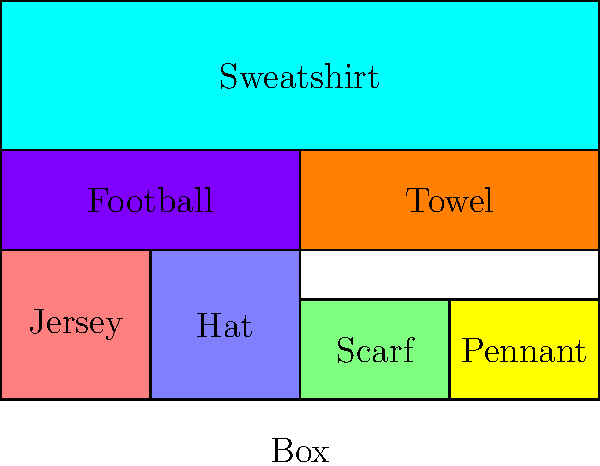You're packing Calgary Stampeders merchandise for shipping. Given a box with dimensions 6 units wide and 4 units tall, and the following items: a jersey (1.5x1.5), a hat (1.5x1.5), a scarf (1.5x1), a pennant (1.5x1), a football (3x1), a towel (3x1), and a sweatshirt (6x1.5), what is the minimum number of layers needed to pack all items efficiently? Let's approach this step-by-step:

1. First, we need to understand the dimensions of the box and the items:
   - Box: 6 units wide, 4 units tall
   - Jersey: 1.5x1.5
   - Hat: 1.5x1.5
   - Scarf: 1.5x1
   - Pennant: 1.5x1
   - Football: 3x1
   - Towel: 3x1
   - Sweatshirt: 6x1.5

2. Now, let's start packing from the bottom:
   - Layer 1 (bottom):
     a. Place the jersey (1.5x1.5) and hat (1.5x1.5) side by side: 3 units wide
     b. Place the scarf (1.5x1) and pennant (1.5x1) next to them: 3 more units wide
     This fills the 6 units width and has a height of 1.5 units

3. For the second layer:
   - Layer 2:
     a. Place the football (3x1) and towel (3x1) side by side
     This fills the 6 units width and adds 1 unit in height, bringing total height to 2.5 units

4. For the third layer:
   - Layer 3:
     a. Place the sweatshirt (6x1.5) on top
     This fills the 6 units width and adds 1.5 units in height, bringing total height to 4 units

5. We have now used all the available height (4 units) and packed all items.

Therefore, we were able to pack all items efficiently using 3 layers.
Answer: 3 layers 